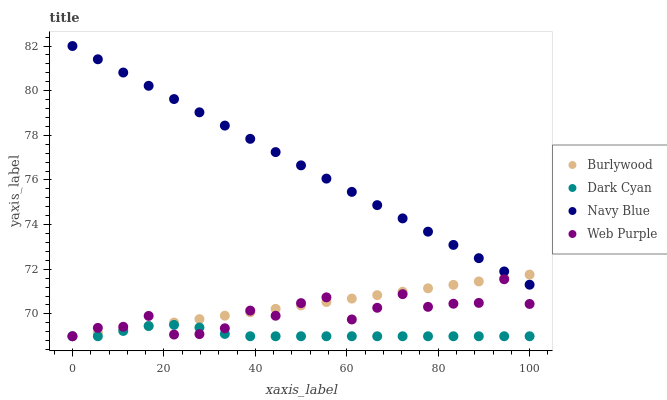Does Dark Cyan have the minimum area under the curve?
Answer yes or no. Yes. Does Navy Blue have the maximum area under the curve?
Answer yes or no. Yes. Does Web Purple have the minimum area under the curve?
Answer yes or no. No. Does Web Purple have the maximum area under the curve?
Answer yes or no. No. Is Navy Blue the smoothest?
Answer yes or no. Yes. Is Web Purple the roughest?
Answer yes or no. Yes. Is Dark Cyan the smoothest?
Answer yes or no. No. Is Dark Cyan the roughest?
Answer yes or no. No. Does Burlywood have the lowest value?
Answer yes or no. Yes. Does Navy Blue have the lowest value?
Answer yes or no. No. Does Navy Blue have the highest value?
Answer yes or no. Yes. Does Web Purple have the highest value?
Answer yes or no. No. Is Web Purple less than Navy Blue?
Answer yes or no. Yes. Is Navy Blue greater than Web Purple?
Answer yes or no. Yes. Does Burlywood intersect Navy Blue?
Answer yes or no. Yes. Is Burlywood less than Navy Blue?
Answer yes or no. No. Is Burlywood greater than Navy Blue?
Answer yes or no. No. Does Web Purple intersect Navy Blue?
Answer yes or no. No. 